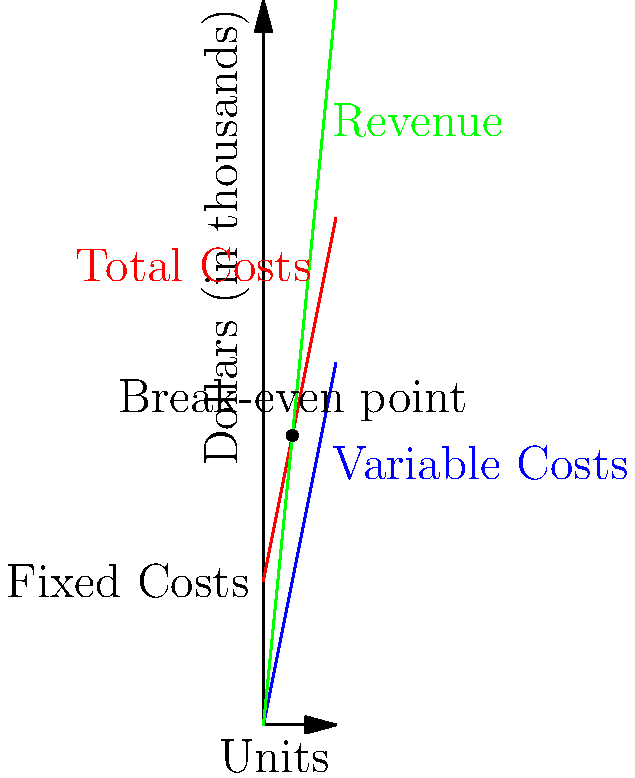As a seasoned accountant providing guidance on financial management for a new business, analyze the break-even graph provided. What is the break-even point in units, and what does this mean for the business in terms of profitability? To determine the break-even point and its significance, let's analyze the graph step-by-step:

1. Identify the lines:
   - Green line: Revenue
   - Red line: Total Costs
   - Blue line: Variable Costs
   - Horizontal line at $200,000: Fixed Costs

2. Locate the break-even point:
   - It's where the Revenue line intersects with the Total Costs line
   - This occurs at 40 units on the x-axis and $400,000 on the y-axis

3. Calculate the break-even point in units:
   - From the graph, we can see it's 40 units

4. Interpret the meaning for the business:
   - At 40 units, Revenue = Total Costs = $400,000
   - Below 40 units, the business operates at a loss
   - Above 40 units, the business starts generating profit

5. Financial implications:
   - Fixed costs are $200,000 (y-intercept of Total Costs line)
   - Each unit contributes $5,000 to cover fixed costs (difference between Revenue and Variable Costs slopes)
   - $200,000 / $5,000 = 40 units to cover fixed costs

6. Profitability analysis:
   - The business needs to sell more than 40 units to be profitable
   - Each unit sold beyond 40 contributes directly to profit
   - This information is crucial for pricing strategies and production planning

In summary, the break-even point of 40 units represents the minimum sales volume required for the business to cover all its costs. It's a critical threshold for financial management and decision-making.
Answer: 40 units; minimum sales to cover all costs and start generating profit 